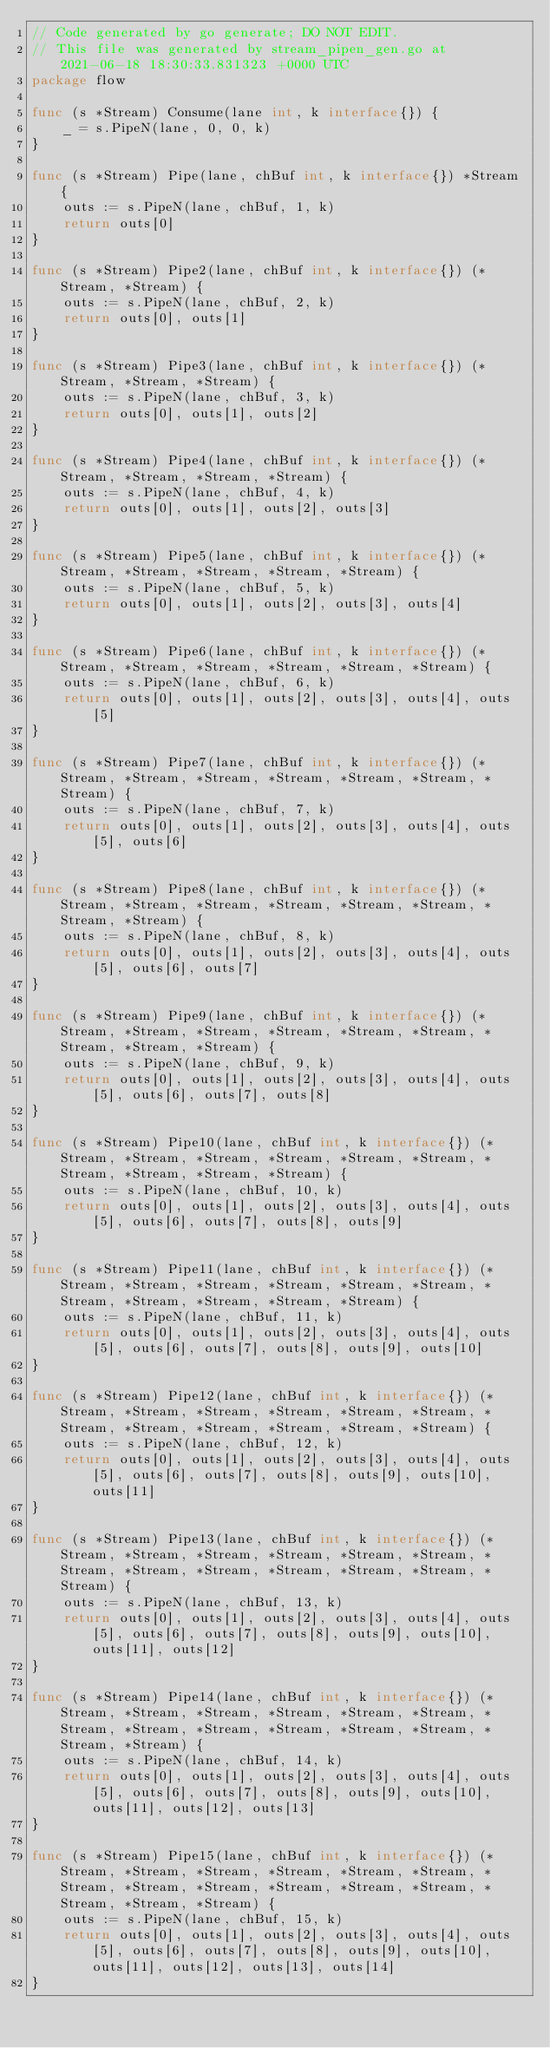<code> <loc_0><loc_0><loc_500><loc_500><_Go_>// Code generated by go generate; DO NOT EDIT.
// This file was generated by stream_pipen_gen.go at 2021-06-18 18:30:33.831323 +0000 UTC
package flow

func (s *Stream) Consume(lane int, k interface{}) {
	_ = s.PipeN(lane, 0, 0, k)
}

func (s *Stream) Pipe(lane, chBuf int, k interface{}) *Stream {
	outs := s.PipeN(lane, chBuf, 1, k)
	return outs[0]
}

func (s *Stream) Pipe2(lane, chBuf int, k interface{}) (*Stream, *Stream) {
	outs := s.PipeN(lane, chBuf, 2, k)
	return outs[0], outs[1]
}

func (s *Stream) Pipe3(lane, chBuf int, k interface{}) (*Stream, *Stream, *Stream) {
	outs := s.PipeN(lane, chBuf, 3, k)
	return outs[0], outs[1], outs[2]
}

func (s *Stream) Pipe4(lane, chBuf int, k interface{}) (*Stream, *Stream, *Stream, *Stream) {
	outs := s.PipeN(lane, chBuf, 4, k)
	return outs[0], outs[1], outs[2], outs[3]
}

func (s *Stream) Pipe5(lane, chBuf int, k interface{}) (*Stream, *Stream, *Stream, *Stream, *Stream) {
	outs := s.PipeN(lane, chBuf, 5, k)
	return outs[0], outs[1], outs[2], outs[3], outs[4]
}

func (s *Stream) Pipe6(lane, chBuf int, k interface{}) (*Stream, *Stream, *Stream, *Stream, *Stream, *Stream) {
	outs := s.PipeN(lane, chBuf, 6, k)
	return outs[0], outs[1], outs[2], outs[3], outs[4], outs[5]
}

func (s *Stream) Pipe7(lane, chBuf int, k interface{}) (*Stream, *Stream, *Stream, *Stream, *Stream, *Stream, *Stream) {
	outs := s.PipeN(lane, chBuf, 7, k)
	return outs[0], outs[1], outs[2], outs[3], outs[4], outs[5], outs[6]
}

func (s *Stream) Pipe8(lane, chBuf int, k interface{}) (*Stream, *Stream, *Stream, *Stream, *Stream, *Stream, *Stream, *Stream) {
	outs := s.PipeN(lane, chBuf, 8, k)
	return outs[0], outs[1], outs[2], outs[3], outs[4], outs[5], outs[6], outs[7]
}

func (s *Stream) Pipe9(lane, chBuf int, k interface{}) (*Stream, *Stream, *Stream, *Stream, *Stream, *Stream, *Stream, *Stream, *Stream) {
	outs := s.PipeN(lane, chBuf, 9, k)
	return outs[0], outs[1], outs[2], outs[3], outs[4], outs[5], outs[6], outs[7], outs[8]
}

func (s *Stream) Pipe10(lane, chBuf int, k interface{}) (*Stream, *Stream, *Stream, *Stream, *Stream, *Stream, *Stream, *Stream, *Stream, *Stream) {
	outs := s.PipeN(lane, chBuf, 10, k)
	return outs[0], outs[1], outs[2], outs[3], outs[4], outs[5], outs[6], outs[7], outs[8], outs[9]
}

func (s *Stream) Pipe11(lane, chBuf int, k interface{}) (*Stream, *Stream, *Stream, *Stream, *Stream, *Stream, *Stream, *Stream, *Stream, *Stream, *Stream) {
	outs := s.PipeN(lane, chBuf, 11, k)
	return outs[0], outs[1], outs[2], outs[3], outs[4], outs[5], outs[6], outs[7], outs[8], outs[9], outs[10]
}

func (s *Stream) Pipe12(lane, chBuf int, k interface{}) (*Stream, *Stream, *Stream, *Stream, *Stream, *Stream, *Stream, *Stream, *Stream, *Stream, *Stream, *Stream) {
	outs := s.PipeN(lane, chBuf, 12, k)
	return outs[0], outs[1], outs[2], outs[3], outs[4], outs[5], outs[6], outs[7], outs[8], outs[9], outs[10], outs[11]
}

func (s *Stream) Pipe13(lane, chBuf int, k interface{}) (*Stream, *Stream, *Stream, *Stream, *Stream, *Stream, *Stream, *Stream, *Stream, *Stream, *Stream, *Stream, *Stream) {
	outs := s.PipeN(lane, chBuf, 13, k)
	return outs[0], outs[1], outs[2], outs[3], outs[4], outs[5], outs[6], outs[7], outs[8], outs[9], outs[10], outs[11], outs[12]
}

func (s *Stream) Pipe14(lane, chBuf int, k interface{}) (*Stream, *Stream, *Stream, *Stream, *Stream, *Stream, *Stream, *Stream, *Stream, *Stream, *Stream, *Stream, *Stream, *Stream) {
	outs := s.PipeN(lane, chBuf, 14, k)
	return outs[0], outs[1], outs[2], outs[3], outs[4], outs[5], outs[6], outs[7], outs[8], outs[9], outs[10], outs[11], outs[12], outs[13]
}

func (s *Stream) Pipe15(lane, chBuf int, k interface{}) (*Stream, *Stream, *Stream, *Stream, *Stream, *Stream, *Stream, *Stream, *Stream, *Stream, *Stream, *Stream, *Stream, *Stream, *Stream) {
	outs := s.PipeN(lane, chBuf, 15, k)
	return outs[0], outs[1], outs[2], outs[3], outs[4], outs[5], outs[6], outs[7], outs[8], outs[9], outs[10], outs[11], outs[12], outs[13], outs[14]
}
</code> 